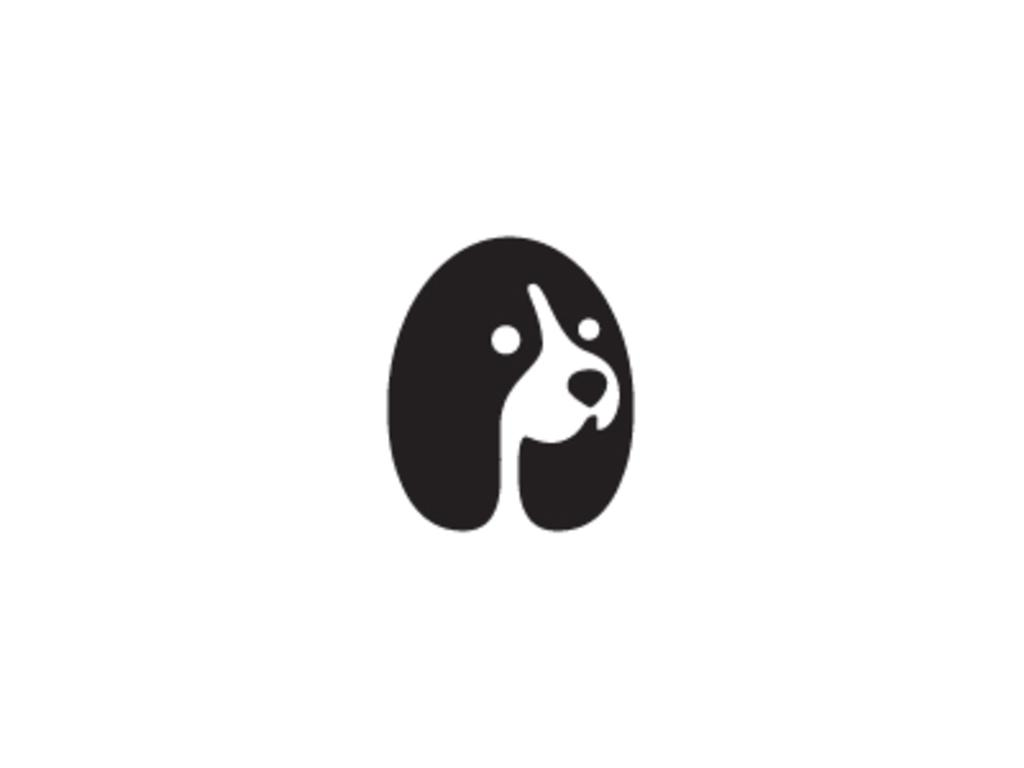What is the main subject of the image? The main subject of the image is a logo of a dog. What color is the background of the image? The background of the image is white. What type of mark can be seen on the dog's collar in the image? There is no dog's collar or mark present in the image; it only features a logo of a dog. How many quarters are visible in the image? There are no quarters present in the image. 